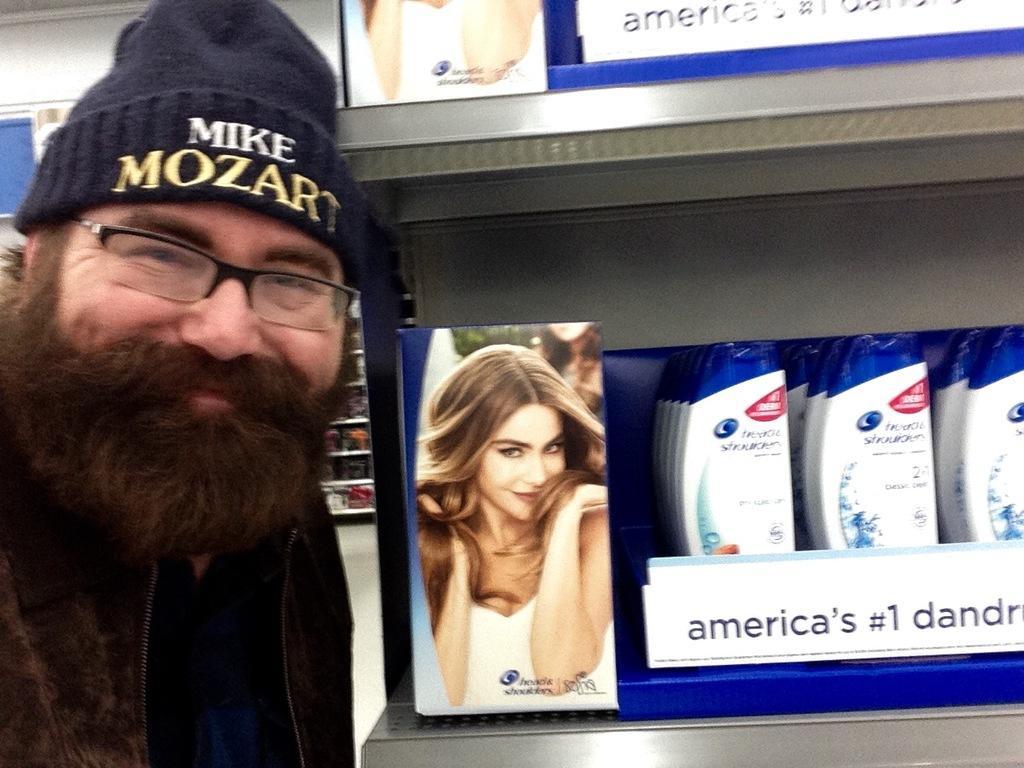Could you give a brief overview of what you see in this image? In this image there is a person on the left side. There is a rack. There are shampoos. There is a photo. In the background there are racks. 